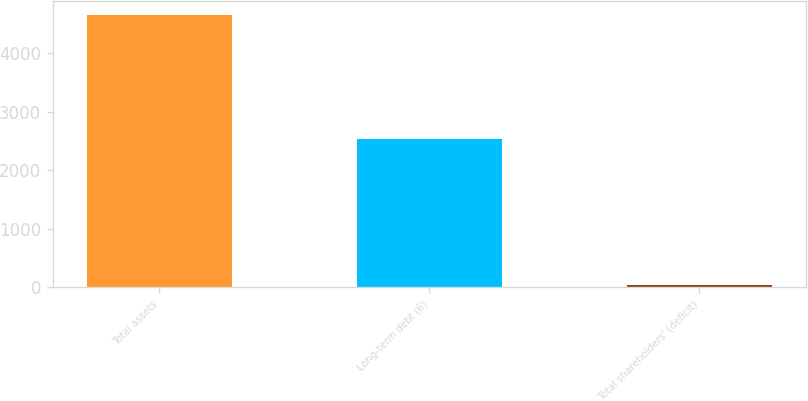<chart> <loc_0><loc_0><loc_500><loc_500><bar_chart><fcel>Total assets<fcel>Long-term debt (6)<fcel>Total shareholders' (deficit)<nl><fcel>4653.8<fcel>2532.1<fcel>42.9<nl></chart> 